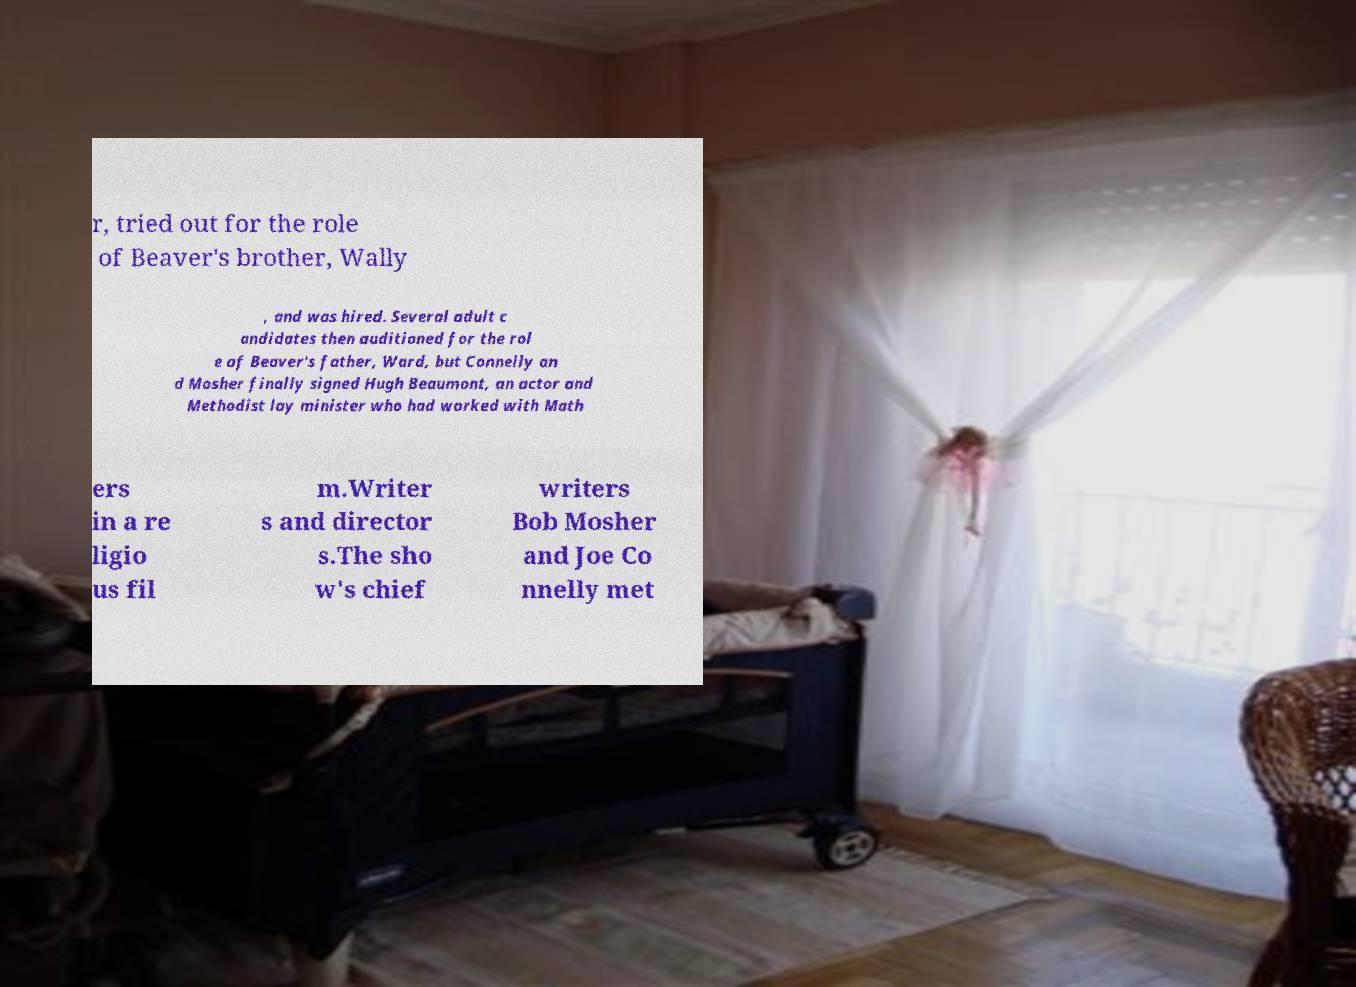What messages or text are displayed in this image? I need them in a readable, typed format. r, tried out for the role of Beaver's brother, Wally , and was hired. Several adult c andidates then auditioned for the rol e of Beaver's father, Ward, but Connelly an d Mosher finally signed Hugh Beaumont, an actor and Methodist lay minister who had worked with Math ers in a re ligio us fil m.Writer s and director s.The sho w's chief writers Bob Mosher and Joe Co nnelly met 